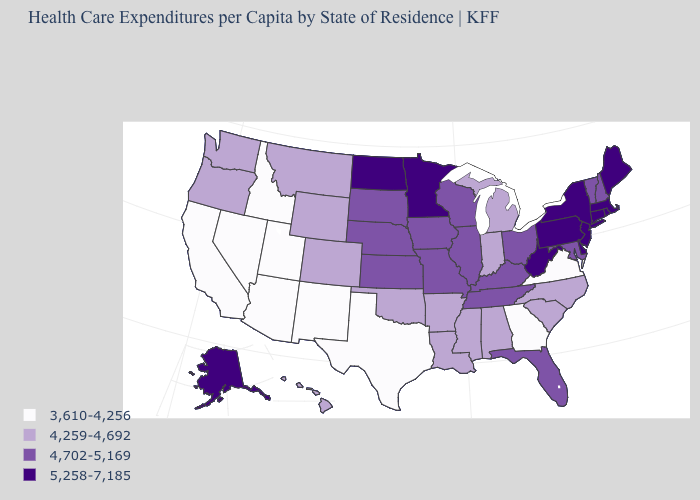Name the states that have a value in the range 3,610-4,256?
Concise answer only. Arizona, California, Georgia, Idaho, Nevada, New Mexico, Texas, Utah, Virginia. Among the states that border New Mexico , which have the highest value?
Write a very short answer. Colorado, Oklahoma. How many symbols are there in the legend?
Write a very short answer. 4. Name the states that have a value in the range 3,610-4,256?
Give a very brief answer. Arizona, California, Georgia, Idaho, Nevada, New Mexico, Texas, Utah, Virginia. Which states have the lowest value in the West?
Quick response, please. Arizona, California, Idaho, Nevada, New Mexico, Utah. What is the lowest value in the USA?
Concise answer only. 3,610-4,256. How many symbols are there in the legend?
Give a very brief answer. 4. Name the states that have a value in the range 5,258-7,185?
Answer briefly. Alaska, Connecticut, Delaware, Maine, Massachusetts, Minnesota, New Jersey, New York, North Dakota, Pennsylvania, Rhode Island, West Virginia. What is the value of Georgia?
Concise answer only. 3,610-4,256. How many symbols are there in the legend?
Quick response, please. 4. Name the states that have a value in the range 5,258-7,185?
Concise answer only. Alaska, Connecticut, Delaware, Maine, Massachusetts, Minnesota, New Jersey, New York, North Dakota, Pennsylvania, Rhode Island, West Virginia. Name the states that have a value in the range 5,258-7,185?
Answer briefly. Alaska, Connecticut, Delaware, Maine, Massachusetts, Minnesota, New Jersey, New York, North Dakota, Pennsylvania, Rhode Island, West Virginia. How many symbols are there in the legend?
Short answer required. 4. Name the states that have a value in the range 3,610-4,256?
Quick response, please. Arizona, California, Georgia, Idaho, Nevada, New Mexico, Texas, Utah, Virginia. What is the value of Montana?
Be succinct. 4,259-4,692. 